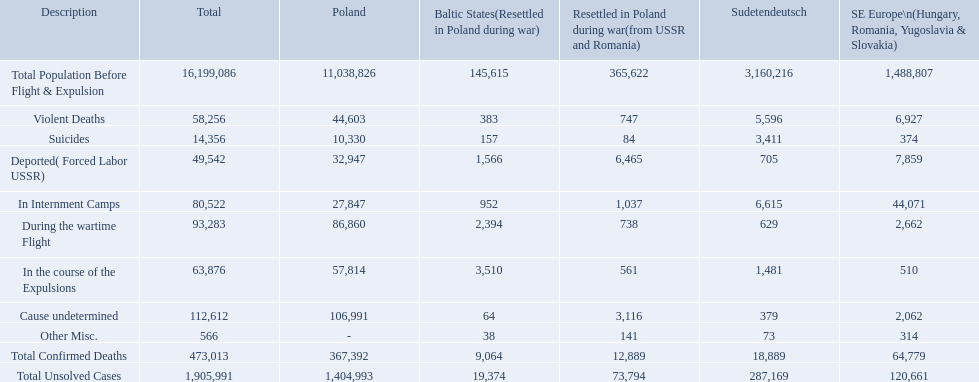What are the numbers of violent deaths across the area? 44,603, 383, 747, 5,596, 6,927. What is the total number of violent deaths of the area? 58,256. What are all the particulars? Total Population Before Flight & Expulsion, Violent Deaths, Suicides, Deported( Forced Labor USSR), In Internment Camps, During the wartime Flight, In the course of the Expulsions, Cause undetermined, Other Misc., Total Confirmed Deaths, Total Unsolved Cases. What was the entire count of casualties? 16,199,086, 58,256, 14,356, 49,542, 80,522, 93,283, 63,876, 112,612, 566, 473,013, 1,905,991. What about only from brutal deaths? 58,256. What are the various descriptions? Total Population Before Flight & Expulsion, Violent Deaths, Suicides, Deported( Forced Labor USSR), In Internment Camps, During the wartime Flight, In the course of the Expulsions, Cause undetermined, Other Misc., Total Confirmed Deaths, Total Unsolved Cases. What is the overall count of fatalities? 16,199,086, 58,256, 14,356, 49,542, 80,522, 93,283, 63,876, 112,612, 566, 473,013, 1,905,991. How many are solely from violent causes? 58,256. Can you list all the descriptions? Total Population Before Flight & Expulsion, Violent Deaths, Suicides, Deported( Forced Labor USSR), In Internment Camps, During the wartime Flight, In the course of the Expulsions, Cause undetermined, Other Misc., Total Confirmed Deaths, Total Unsolved Cases. What is the cumulative number of deaths? 16,199,086, 58,256, 14,356, 49,542, 80,522, 93,283, 63,876, 112,612, 566, 473,013, 1,905,991. How many of those are specifically from violent incidents? 58,256. What was the total number of confirmed fatalities in the baltic states? 9,064. How many fatalities had an unspecified cause? 64. How many deaths in the area were classified as miscellaneous? 38. Which was higher, deaths with an unknown cause or those categorized as miscellaneous? Cause undetermined. What is the total count of confirmed deaths in the baltic states? 9,064. How many deaths had an uncertain cause? 64. How many deaths within that region were categorized as miscellaneous? 38. Were there more deaths with an unclear cause or those considered miscellaneous? Cause undetermined. In each category, what is the count of deaths for the baltic states? 145,615, 383, 157, 1,566, 952, 2,394, 3,510, 64, 38, 9,064, 19,374. What is the total of undetermined cause deaths in the baltic states? 64. What is the total number of other miscellaneous deaths in the baltic states? 38. Which type of death is more common: those with undetermined causes or miscellaneous ones? Cause undetermined. 